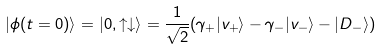Convert formula to latex. <formula><loc_0><loc_0><loc_500><loc_500>| \phi ( t = 0 ) \rangle = | 0 , \uparrow \downarrow \rangle = \frac { 1 } { \sqrt { 2 } } ( \gamma _ { + } | v _ { + } \rangle - \gamma _ { - } | v _ { - } \rangle - | D _ { - } \rangle )</formula> 